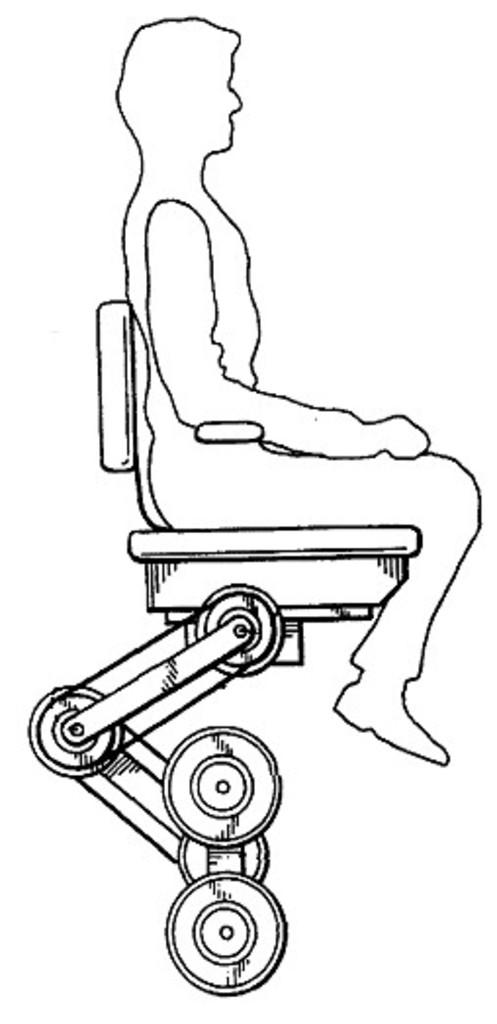What is depicted in the image? There is a sketch of a person in the image. What is the person doing in the sketch? The person is sitting on a chair. What can be observed about the chair in the sketch? There are 4 round things attached to the chair. What is the color of the background in the image? The background of the image is white. How many trees are visible in the image? There are no trees visible in the image; the background is white. What type of stone is being weighed on the scale in the image? There is no stone or scale present in the image. 